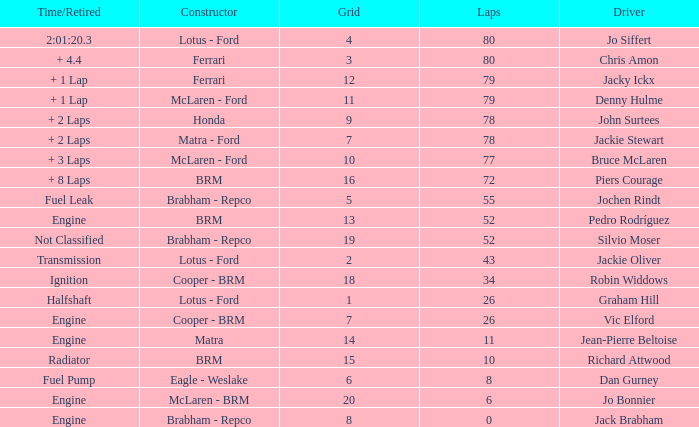What driver has a grid greater than 19? Jo Bonnier. 